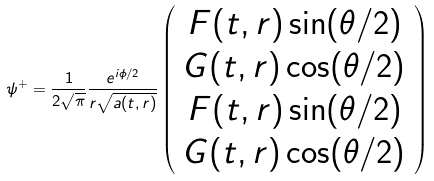Convert formula to latex. <formula><loc_0><loc_0><loc_500><loc_500>\psi ^ { + } = \frac { 1 } { 2 \sqrt { \pi } } \frac { e ^ { i \phi / 2 } } { r \sqrt { a ( t , r ) } } \left ( \begin{array} { c } F ( t , r ) \sin ( \theta / 2 ) \\ G ( t , r ) \cos ( \theta / 2 ) \\ F ( t , r ) \sin ( \theta / 2 ) \\ G ( t , r ) \cos ( \theta / 2 ) \end{array} \right )</formula> 